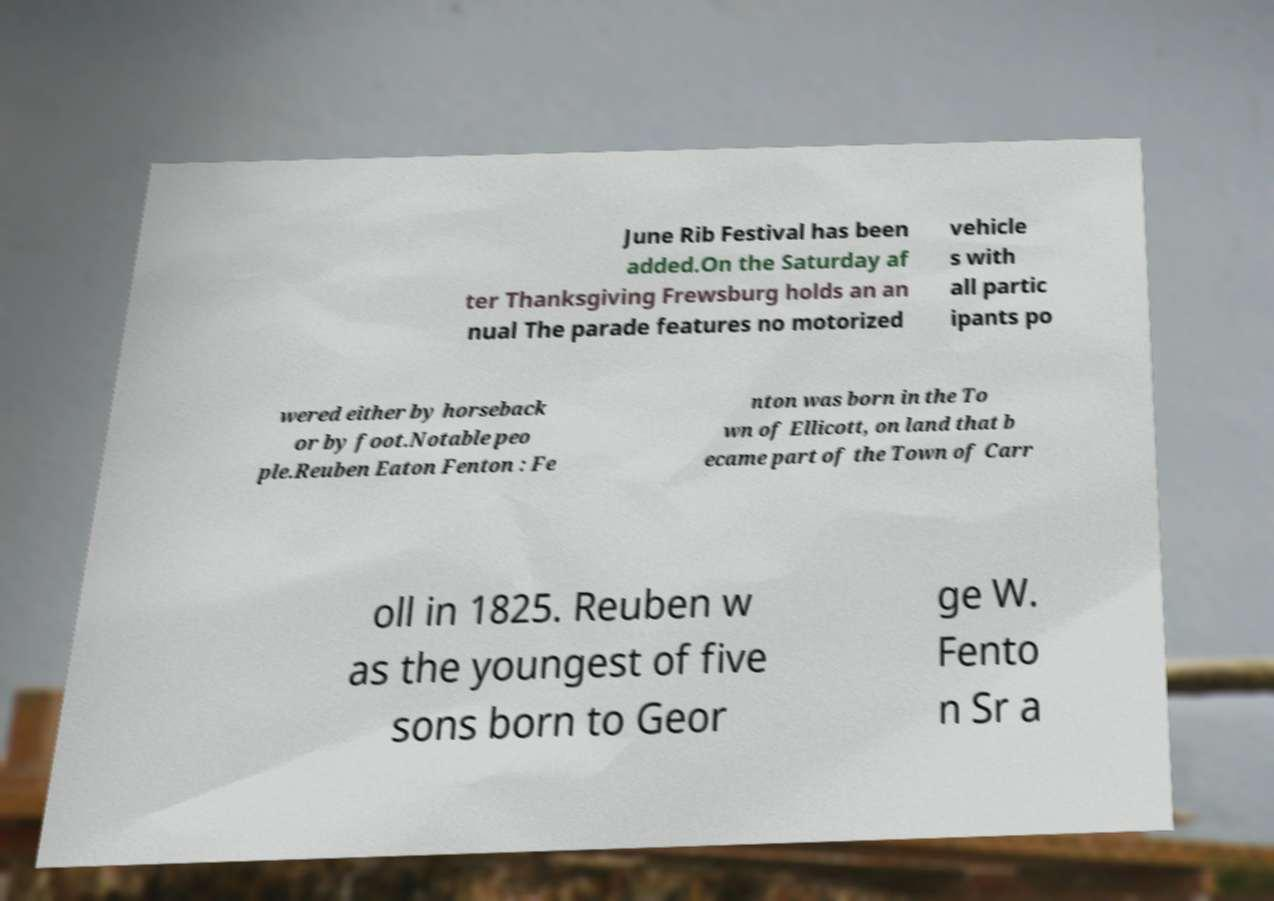Could you assist in decoding the text presented in this image and type it out clearly? June Rib Festival has been added.On the Saturday af ter Thanksgiving Frewsburg holds an an nual The parade features no motorized vehicle s with all partic ipants po wered either by horseback or by foot.Notable peo ple.Reuben Eaton Fenton : Fe nton was born in the To wn of Ellicott, on land that b ecame part of the Town of Carr oll in 1825. Reuben w as the youngest of five sons born to Geor ge W. Fento n Sr a 